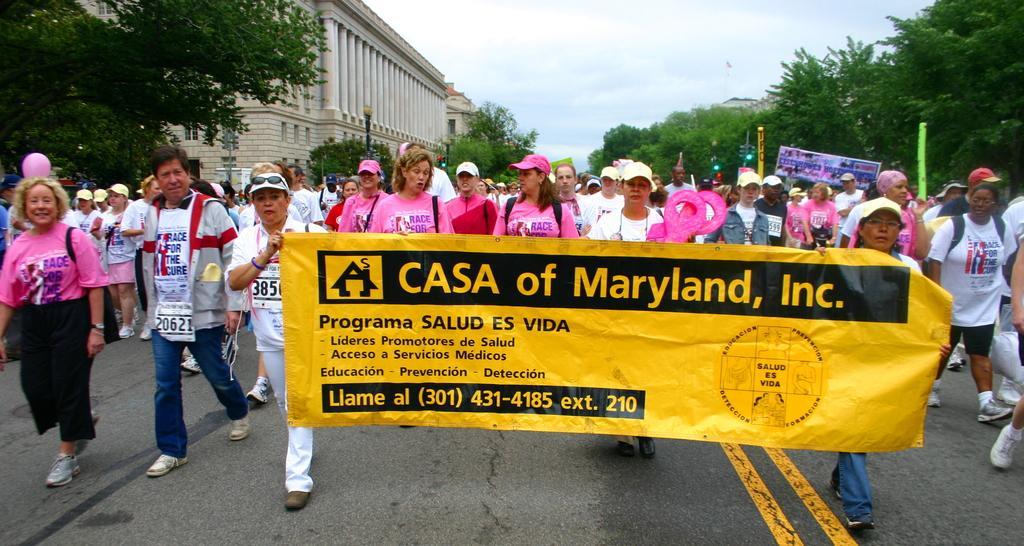How would you summarize this image in a sentence or two? There are people holding a flex in the foreground area of the image, there are trees, buildings, poles and the sky in the background. 